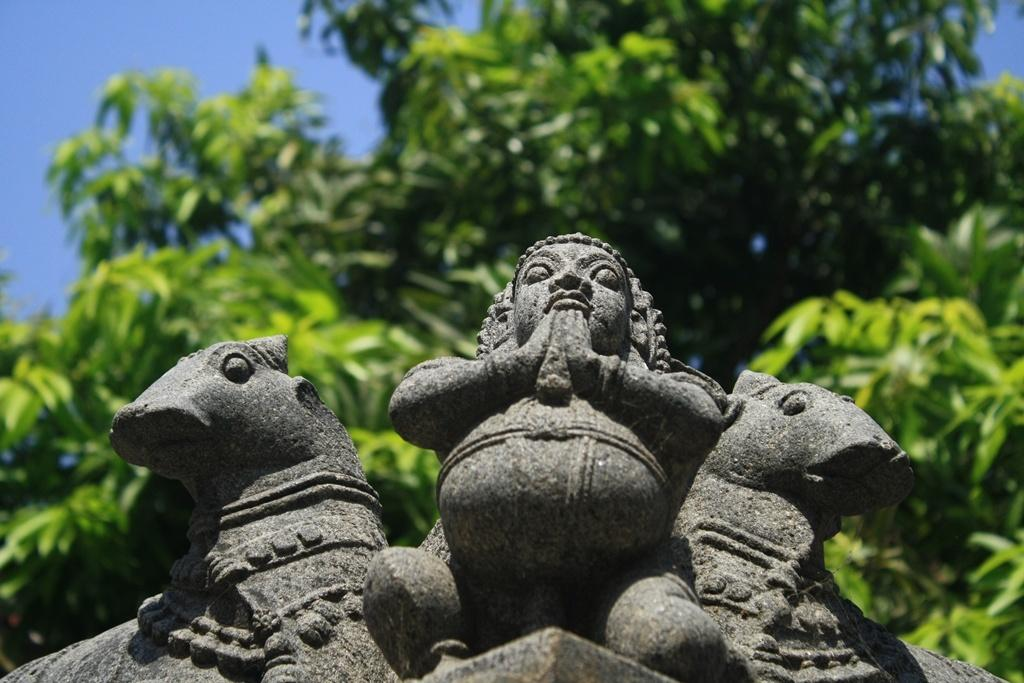What type of art is present in the image? There are sculptures in the image. What can be seen in the background of the image? There are trees and the sky visible in the background of the image. What is the coast like in the image? There is no coast present in the image; it features sculptures and a background with trees and the sky. 